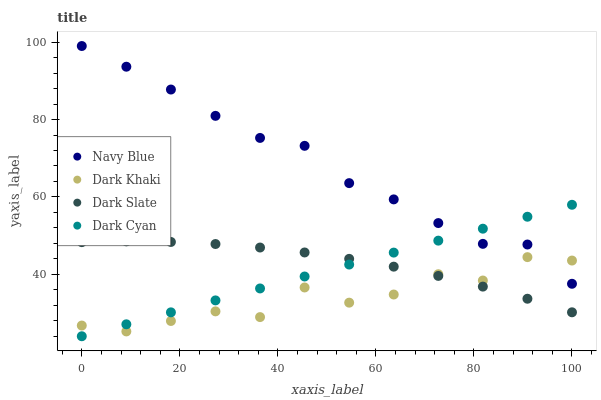Does Dark Khaki have the minimum area under the curve?
Answer yes or no. Yes. Does Navy Blue have the maximum area under the curve?
Answer yes or no. Yes. Does Dark Cyan have the minimum area under the curve?
Answer yes or no. No. Does Dark Cyan have the maximum area under the curve?
Answer yes or no. No. Is Dark Cyan the smoothest?
Answer yes or no. Yes. Is Dark Khaki the roughest?
Answer yes or no. Yes. Is Navy Blue the smoothest?
Answer yes or no. No. Is Navy Blue the roughest?
Answer yes or no. No. Does Dark Cyan have the lowest value?
Answer yes or no. Yes. Does Navy Blue have the lowest value?
Answer yes or no. No. Does Navy Blue have the highest value?
Answer yes or no. Yes. Does Dark Cyan have the highest value?
Answer yes or no. No. Is Dark Slate less than Navy Blue?
Answer yes or no. Yes. Is Navy Blue greater than Dark Slate?
Answer yes or no. Yes. Does Dark Slate intersect Dark Khaki?
Answer yes or no. Yes. Is Dark Slate less than Dark Khaki?
Answer yes or no. No. Is Dark Slate greater than Dark Khaki?
Answer yes or no. No. Does Dark Slate intersect Navy Blue?
Answer yes or no. No. 